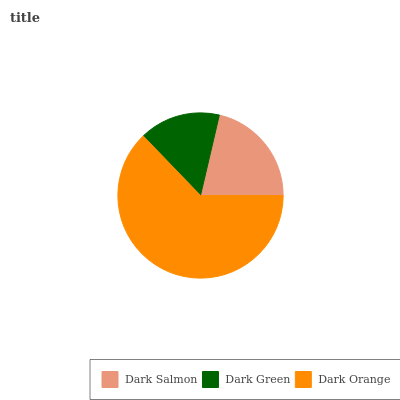Is Dark Green the minimum?
Answer yes or no. Yes. Is Dark Orange the maximum?
Answer yes or no. Yes. Is Dark Orange the minimum?
Answer yes or no. No. Is Dark Green the maximum?
Answer yes or no. No. Is Dark Orange greater than Dark Green?
Answer yes or no. Yes. Is Dark Green less than Dark Orange?
Answer yes or no. Yes. Is Dark Green greater than Dark Orange?
Answer yes or no. No. Is Dark Orange less than Dark Green?
Answer yes or no. No. Is Dark Salmon the high median?
Answer yes or no. Yes. Is Dark Salmon the low median?
Answer yes or no. Yes. Is Dark Orange the high median?
Answer yes or no. No. Is Dark Orange the low median?
Answer yes or no. No. 